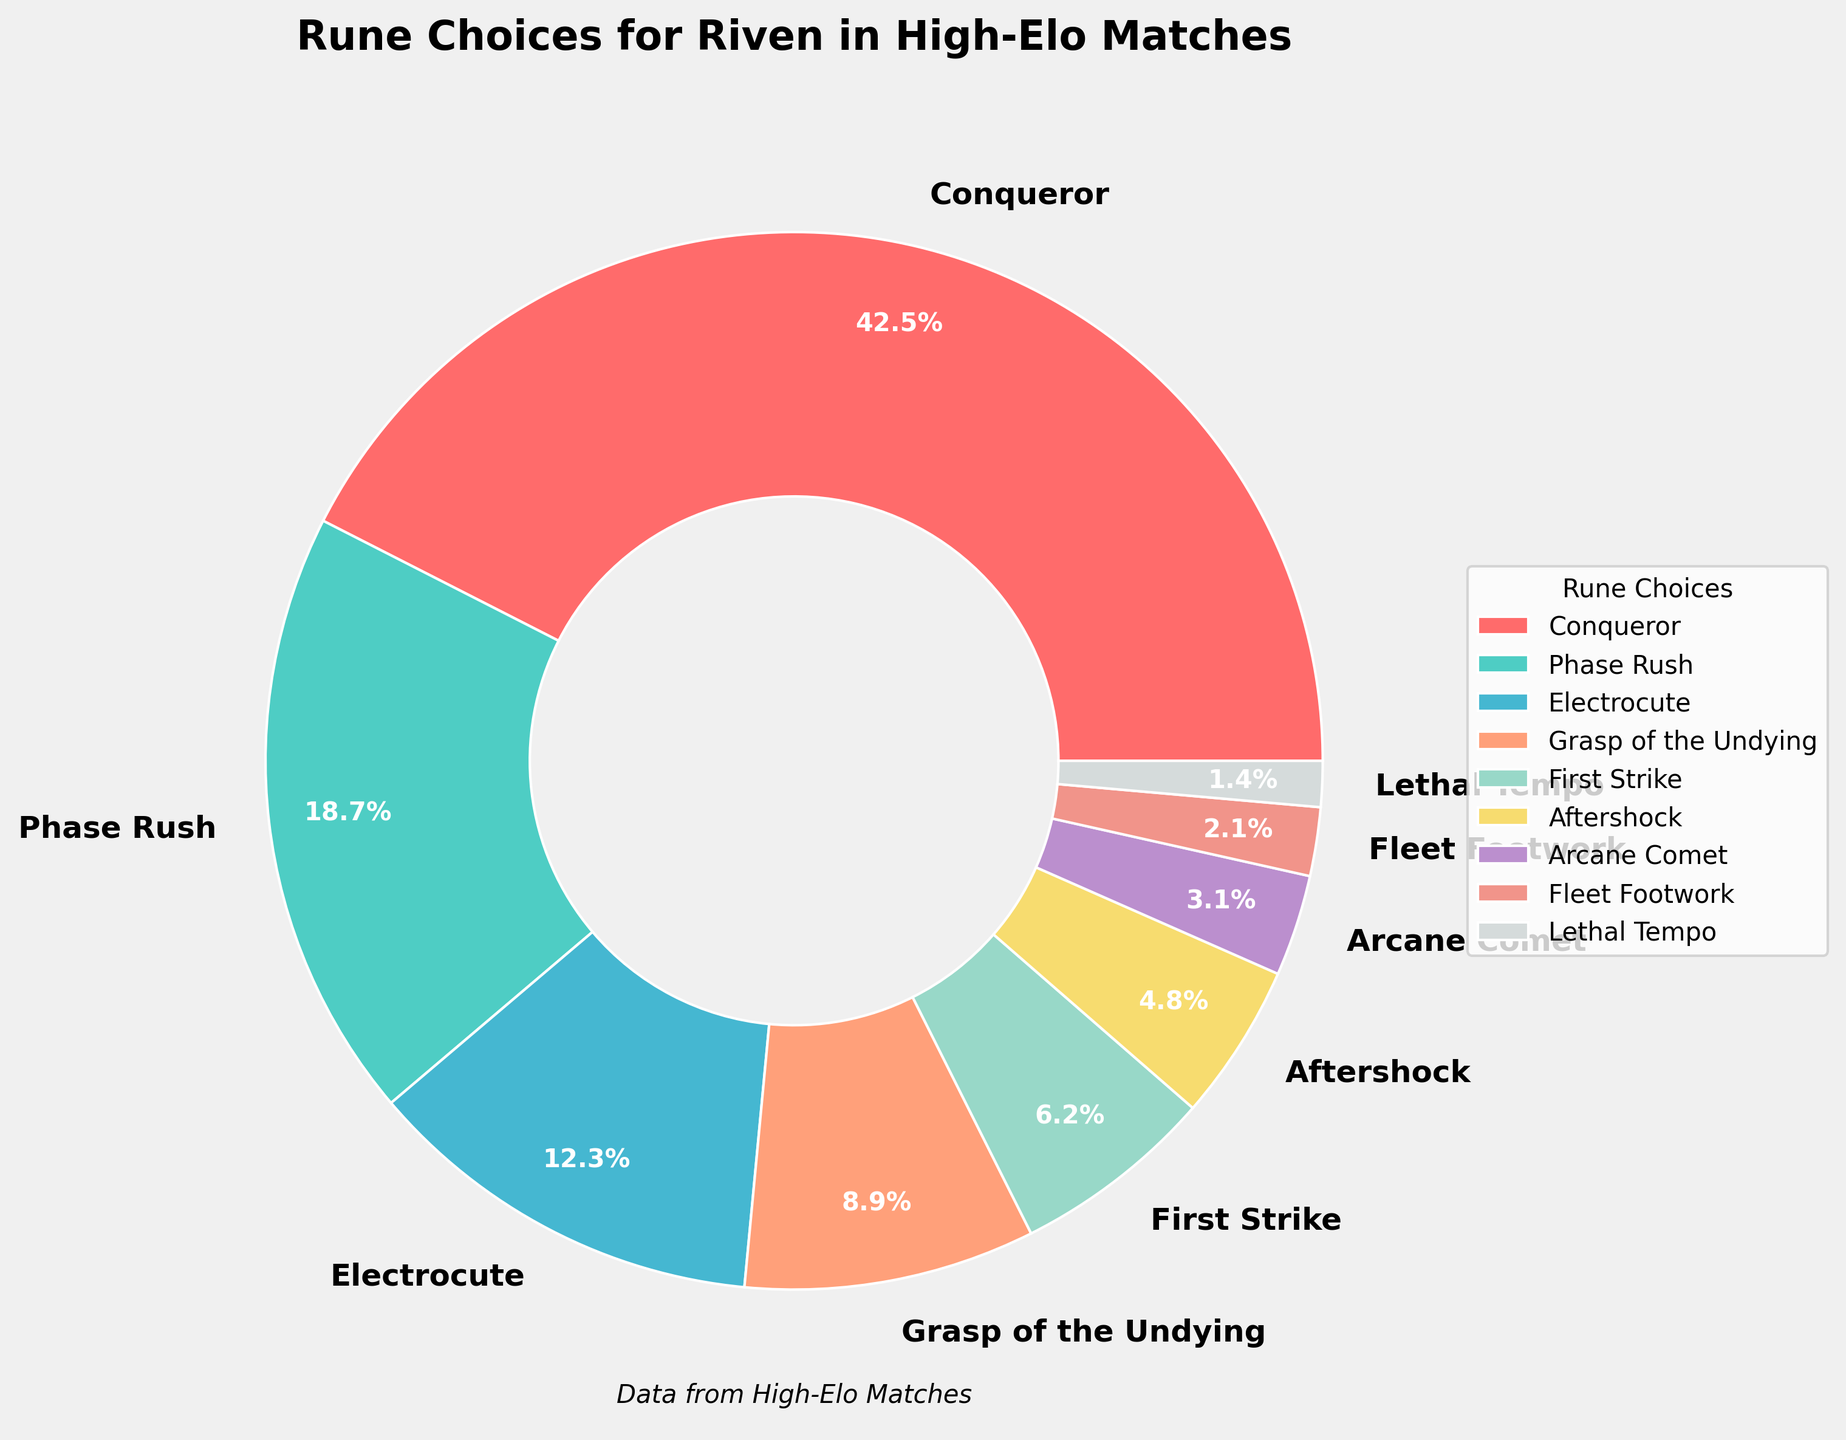What's the dominant rune choice for Riven in high-elo matches? The pie chart shows each rune's percentage, and the largest section represents the dominating choice. Conqueror has the largest percentage at 42.5%, making it the dominant choice.
Answer: Conqueror How does the percentage of Phase Rush compare to Electrocute? Phase Rush accounts for 18.7%, while Electrocute accounts for 12.3%. Thus, Phase Rush has a higher percentage than Electrocute.
Answer: Phase Rush has a higher percentage What's the total percentage of the three least popular rune choices for Riven? The three least popular rune choices are Fleet Footwork (2.1%), Lethal Tempo (1.4%), and Arcane Comet (3.1%). Summing them up: 2.1% + 1.4% + 3.1% = 6.6%.
Answer: 6.6% If you combine the percentages of the top two most popular rune choices, what does it add up to? The top two rune choices are Conqueror (42.5%) and Phase Rush (18.7%). Adding them together: 42.5% + 18.7% = 61.2%.
Answer: 61.2% Which rune occupies the smallest portion of the pie chart? By looking at the pie chart sections, the smallest portion belongs to Lethal Tempo with a percentage of 1.4%.
Answer: Lethal Tempo How much larger is Conqueror's percentage compared to First Strike? Conqueror's percentage is 42.5%, and First Strike's percentage is 6.2%. Subtracting First Strike from Conqueror: 42.5% - 6.2% = 36.3%.
Answer: 36.3% What fraction of the total does Grasp of the Undying and Aftershock together represent? Grasp of the Undying is 8.9%, and Aftershock is 4.8%. Adding them together: 8.9% + 4.8% = 13.7%. This represents 13.7% of the total, or in fraction form, 13.7/100 which simplifies to 137/1000.
Answer: 137/1000 Visually, what is the color representing Electrocute as depicted in the pie chart? The pie chart assigns specific colors to each rune. The section labeled Electrocute is colored blue.
Answer: Blue 